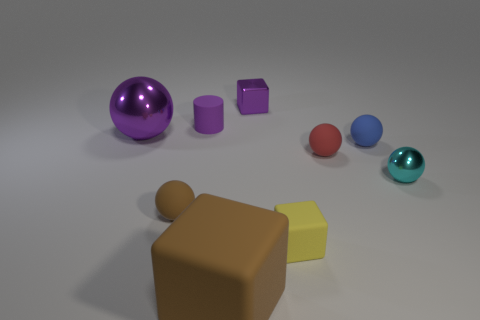Are there the same number of tiny purple metallic blocks that are to the left of the purple sphere and yellow rubber things that are left of the large brown matte object?
Keep it short and to the point. Yes. What is the size of the metal ball that is left of the tiny cyan ball?
Your answer should be compact. Large. Does the big cube have the same color as the small metallic cube?
Make the answer very short. No. Is there anything else that is the same shape as the tiny yellow matte thing?
Your answer should be very brief. Yes. There is a block that is the same color as the rubber cylinder; what material is it?
Give a very brief answer. Metal. Are there an equal number of big metallic objects that are in front of the blue thing and small purple rubber cylinders?
Give a very brief answer. No. Are there any small spheres to the left of the blue rubber thing?
Provide a succinct answer. Yes. Does the cyan object have the same shape as the purple thing on the right side of the brown rubber cube?
Your answer should be very brief. No. The small block that is made of the same material as the small cylinder is what color?
Ensure brevity in your answer.  Yellow. What color is the big shiny object?
Offer a terse response. Purple. 